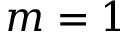<formula> <loc_0><loc_0><loc_500><loc_500>m = 1</formula> 